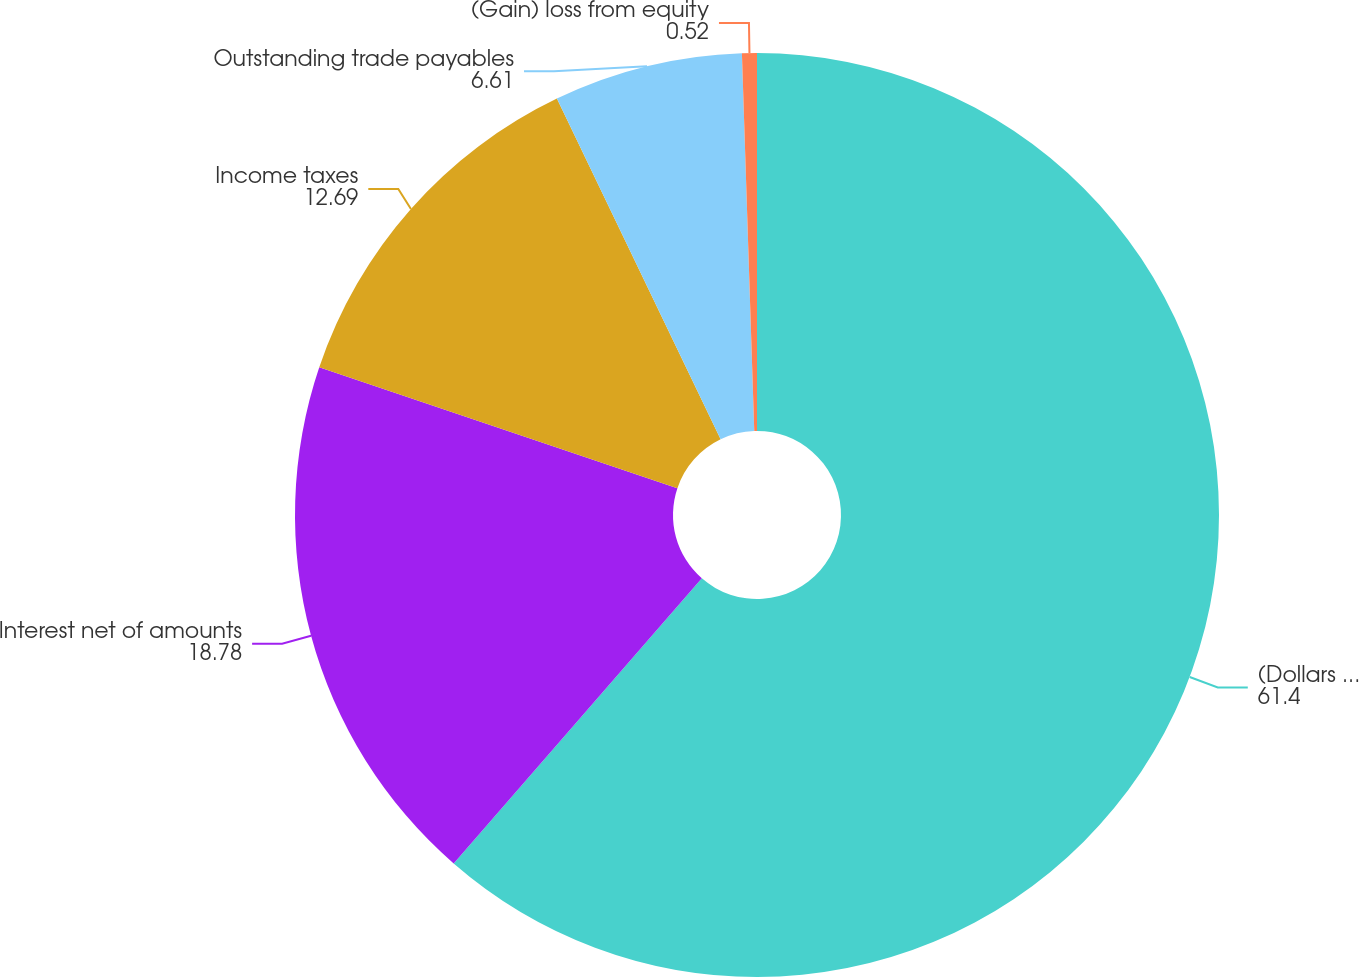Convert chart to OTSL. <chart><loc_0><loc_0><loc_500><loc_500><pie_chart><fcel>(Dollars in millions)<fcel>Interest net of amounts<fcel>Income taxes<fcel>Outstanding trade payables<fcel>(Gain) loss from equity<nl><fcel>61.4%<fcel>18.78%<fcel>12.69%<fcel>6.61%<fcel>0.52%<nl></chart> 